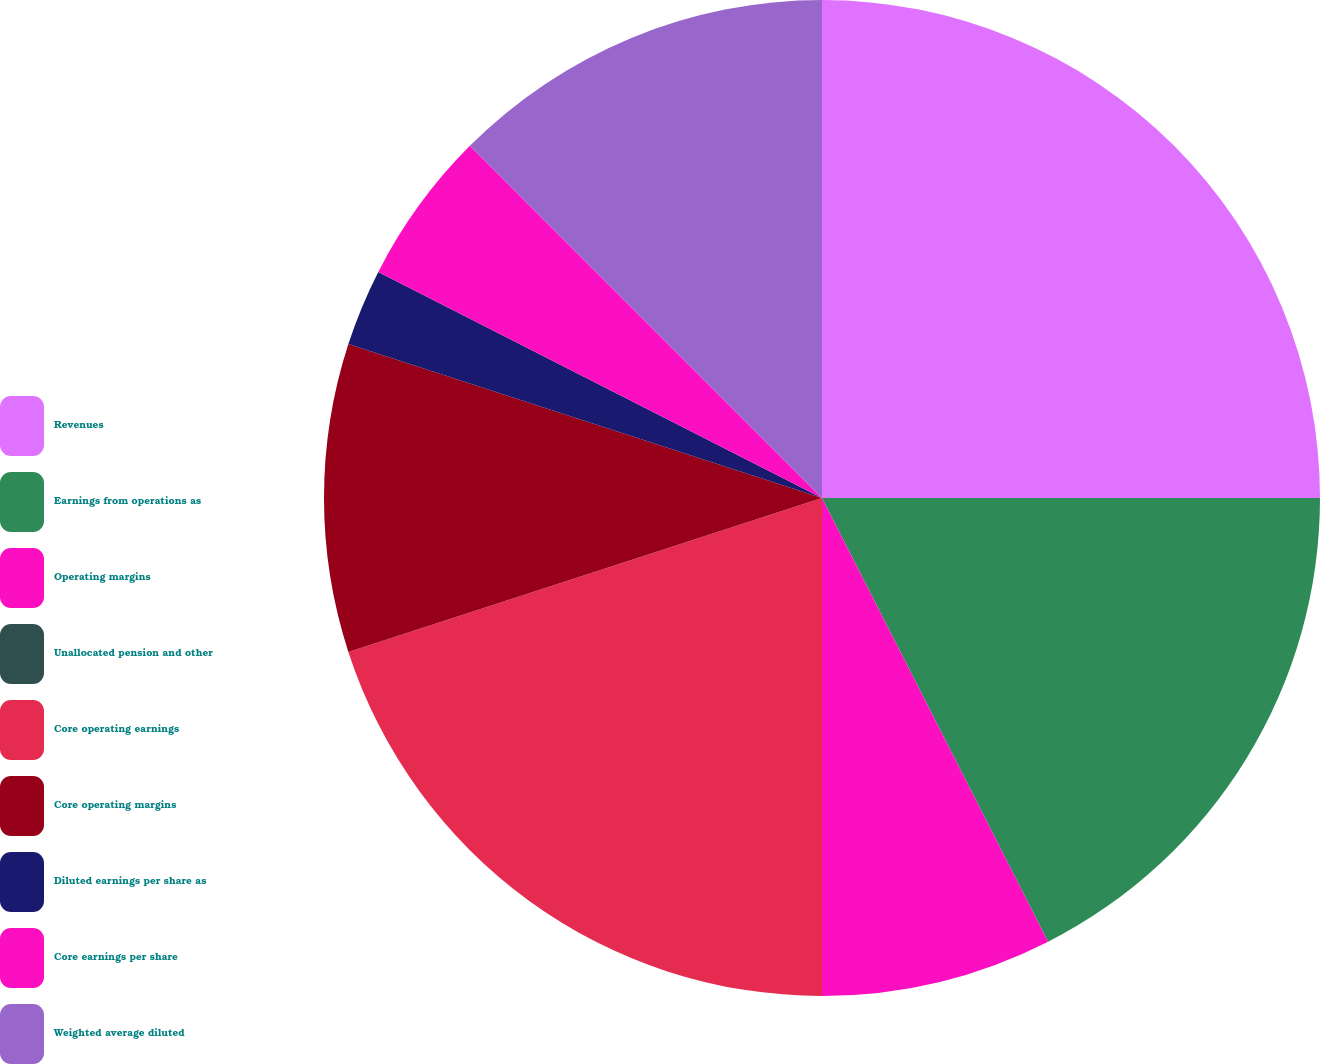Convert chart. <chart><loc_0><loc_0><loc_500><loc_500><pie_chart><fcel>Revenues<fcel>Earnings from operations as<fcel>Operating margins<fcel>Unallocated pension and other<fcel>Core operating earnings<fcel>Core operating margins<fcel>Diluted earnings per share as<fcel>Core earnings per share<fcel>Weighted average diluted<nl><fcel>25.0%<fcel>17.5%<fcel>7.5%<fcel>0.0%<fcel>20.0%<fcel>10.0%<fcel>2.5%<fcel>5.0%<fcel>12.5%<nl></chart> 